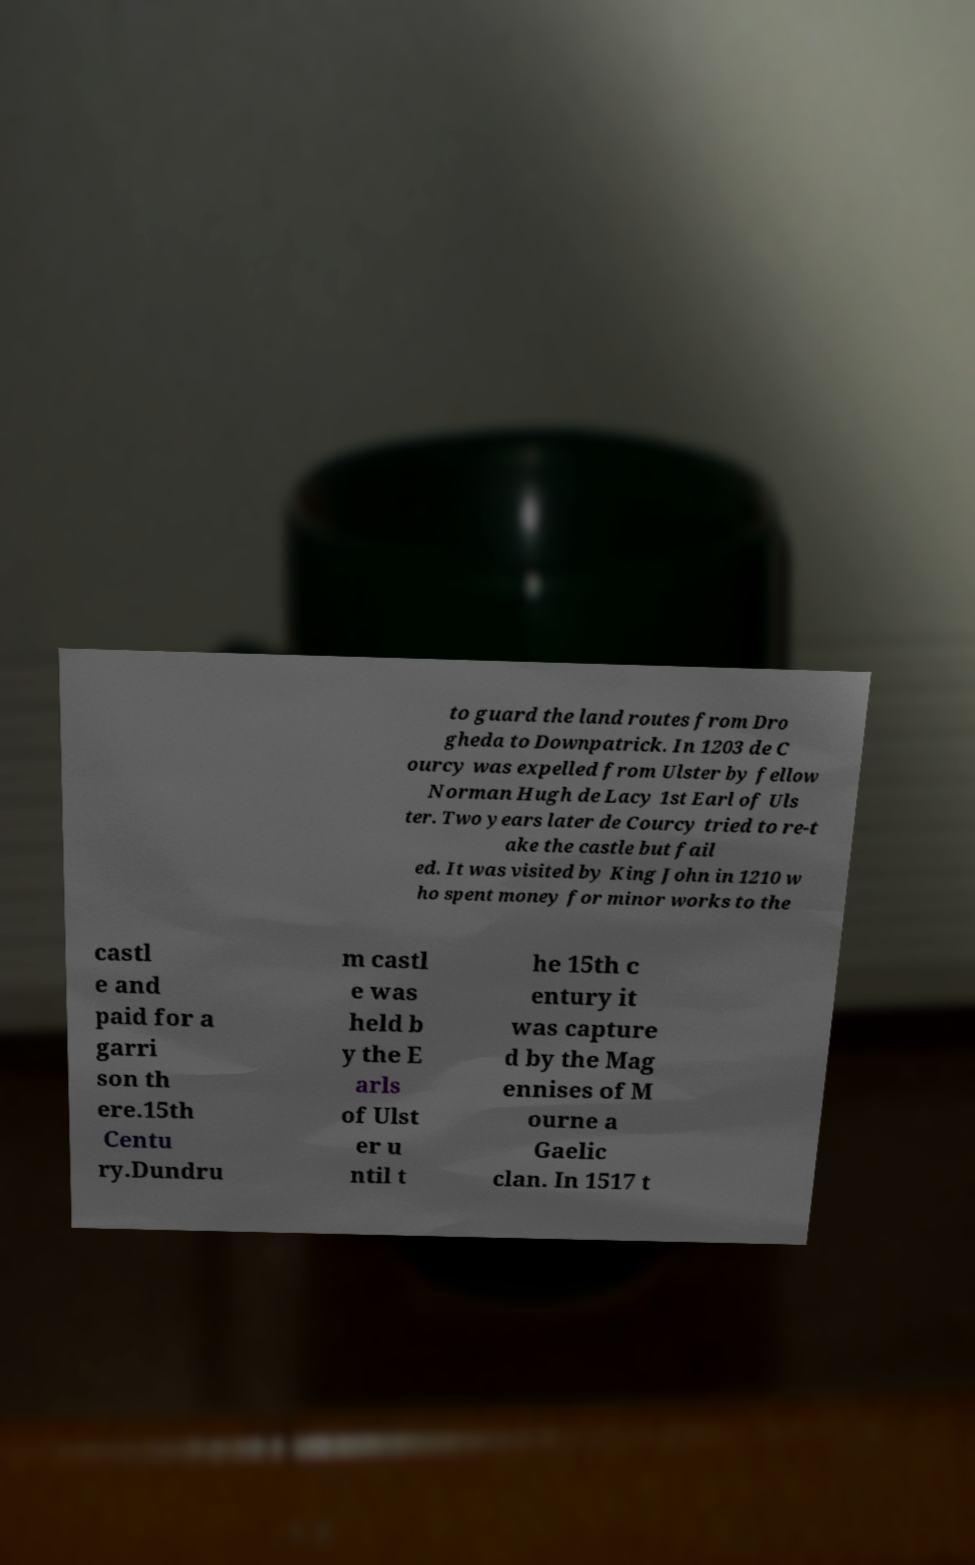Please identify and transcribe the text found in this image. to guard the land routes from Dro gheda to Downpatrick. In 1203 de C ourcy was expelled from Ulster by fellow Norman Hugh de Lacy 1st Earl of Uls ter. Two years later de Courcy tried to re-t ake the castle but fail ed. It was visited by King John in 1210 w ho spent money for minor works to the castl e and paid for a garri son th ere.15th Centu ry.Dundru m castl e was held b y the E arls of Ulst er u ntil t he 15th c entury it was capture d by the Mag ennises of M ourne a Gaelic clan. In 1517 t 